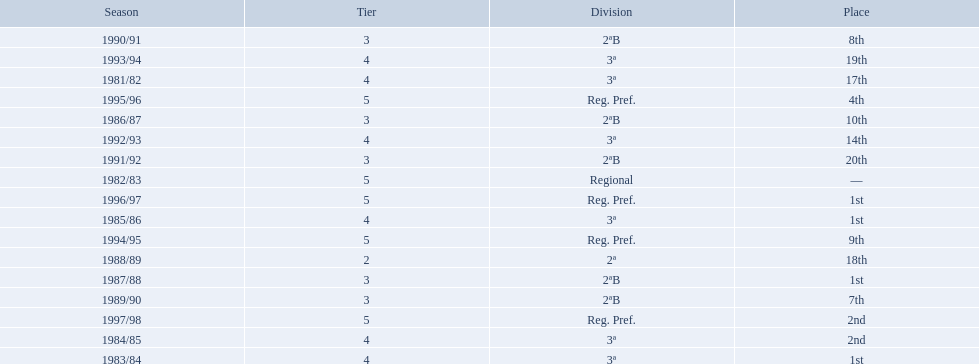In what years did the team finish 17th or worse? 1981/82, 1988/89, 1991/92, 1993/94. Of those, in which year the team finish worse? 1991/92. 